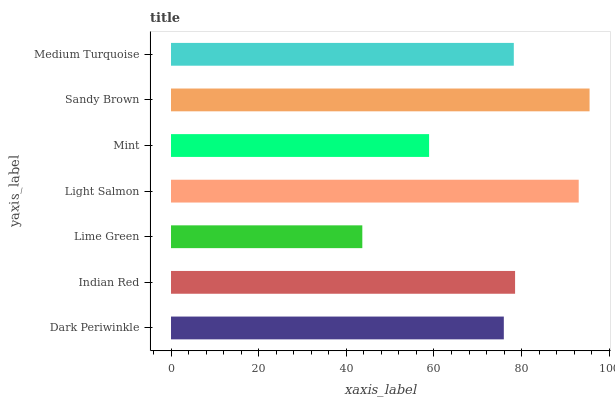Is Lime Green the minimum?
Answer yes or no. Yes. Is Sandy Brown the maximum?
Answer yes or no. Yes. Is Indian Red the minimum?
Answer yes or no. No. Is Indian Red the maximum?
Answer yes or no. No. Is Indian Red greater than Dark Periwinkle?
Answer yes or no. Yes. Is Dark Periwinkle less than Indian Red?
Answer yes or no. Yes. Is Dark Periwinkle greater than Indian Red?
Answer yes or no. No. Is Indian Red less than Dark Periwinkle?
Answer yes or no. No. Is Medium Turquoise the high median?
Answer yes or no. Yes. Is Medium Turquoise the low median?
Answer yes or no. Yes. Is Lime Green the high median?
Answer yes or no. No. Is Sandy Brown the low median?
Answer yes or no. No. 